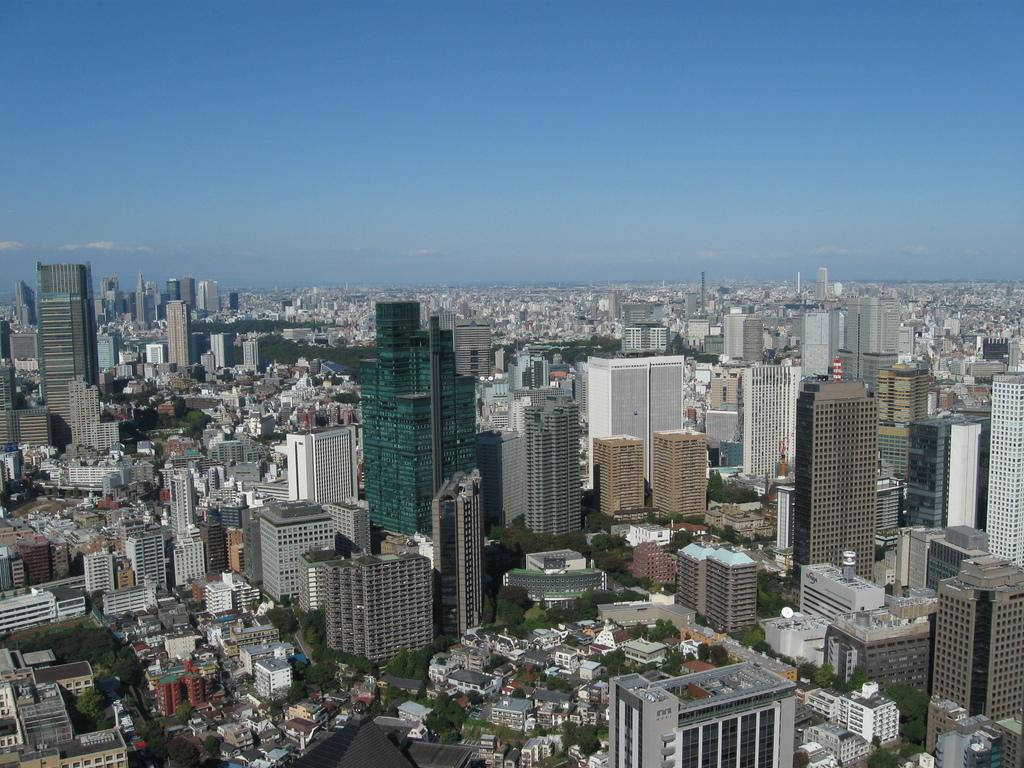What type of location is depicted in the image? The image depicts a city. What types of structures can be seen in the city? There are many buildings, including skyscrapers and houses, in the city. What natural elements are present in the city? Trees are visible in the city, and a river is also visible. What man-made elements are present in the city? Roads are present in the city. What can be seen in the sky in the image? The sky is visible in the image, and clouds are present in the sky. What type of coil can be seen in the image? There is no coil present in the image. What color is the powder on the riverbank in the image? There is no powder present on the riverbank in the image. 